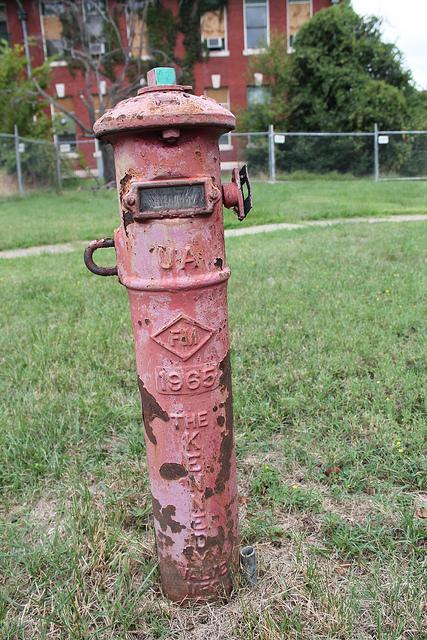Is this post showing signs of age?
Quick response, please. Yes. What year can be read on the post?
Keep it brief. 1965. What number is on the bottom part of the hydrant?
Give a very brief answer. 1965. Is this a school?
Quick response, please. No. 